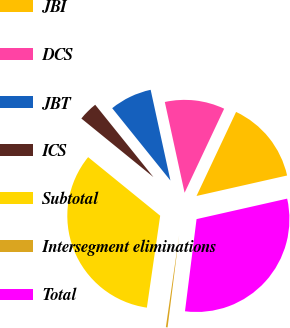<chart> <loc_0><loc_0><loc_500><loc_500><pie_chart><fcel>JBI<fcel>DCS<fcel>JBT<fcel>ICS<fcel>Subtotal<fcel>Intersegment eliminations<fcel>Total<nl><fcel>14.46%<fcel>10.42%<fcel>7.37%<fcel>3.35%<fcel>33.58%<fcel>0.3%<fcel>30.53%<nl></chart> 